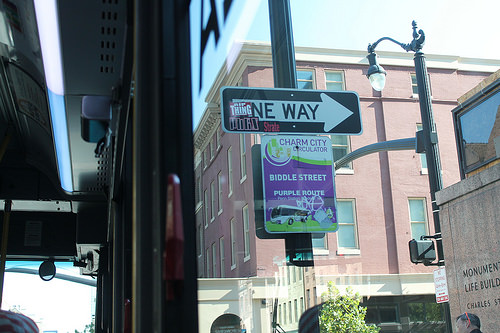<image>
Is there a building behind the sign? Yes. From this viewpoint, the building is positioned behind the sign, with the sign partially or fully occluding the building. 